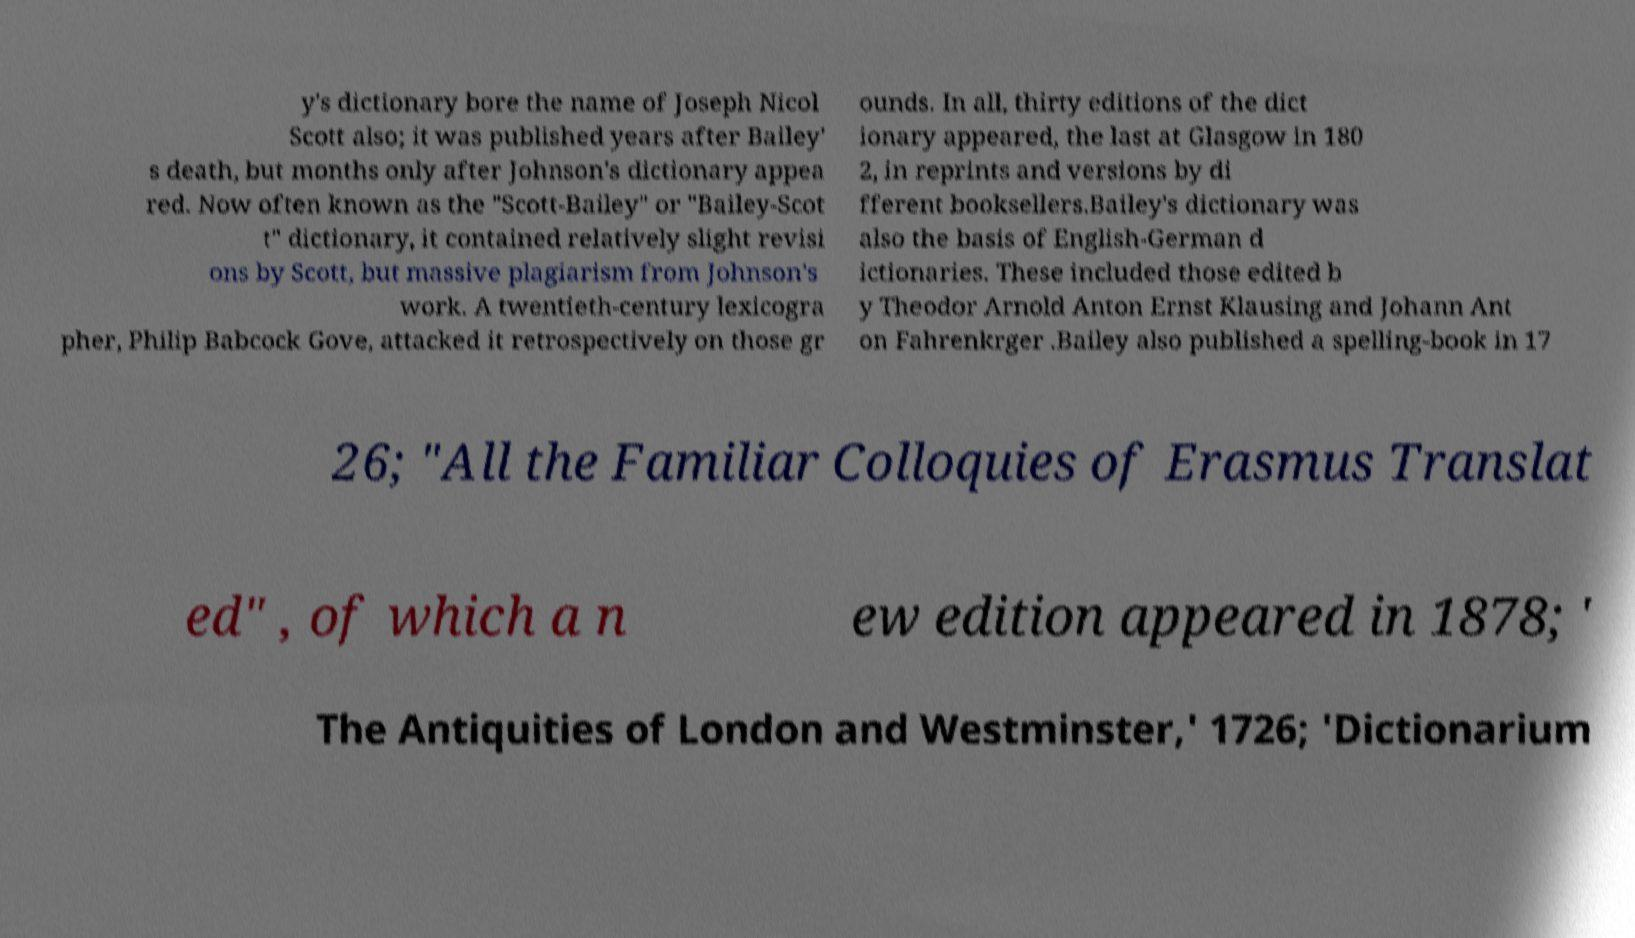Could you assist in decoding the text presented in this image and type it out clearly? y's dictionary bore the name of Joseph Nicol Scott also; it was published years after Bailey' s death, but months only after Johnson's dictionary appea red. Now often known as the "Scott-Bailey" or "Bailey-Scot t" dictionary, it contained relatively slight revisi ons by Scott, but massive plagiarism from Johnson's work. A twentieth-century lexicogra pher, Philip Babcock Gove, attacked it retrospectively on those gr ounds. In all, thirty editions of the dict ionary appeared, the last at Glasgow in 180 2, in reprints and versions by di fferent booksellers.Bailey's dictionary was also the basis of English-German d ictionaries. These included those edited b y Theodor Arnold Anton Ernst Klausing and Johann Ant on Fahrenkrger .Bailey also published a spelling-book in 17 26; "All the Familiar Colloquies of Erasmus Translat ed" , of which a n ew edition appeared in 1878; ' The Antiquities of London and Westminster,' 1726; 'Dictionarium 